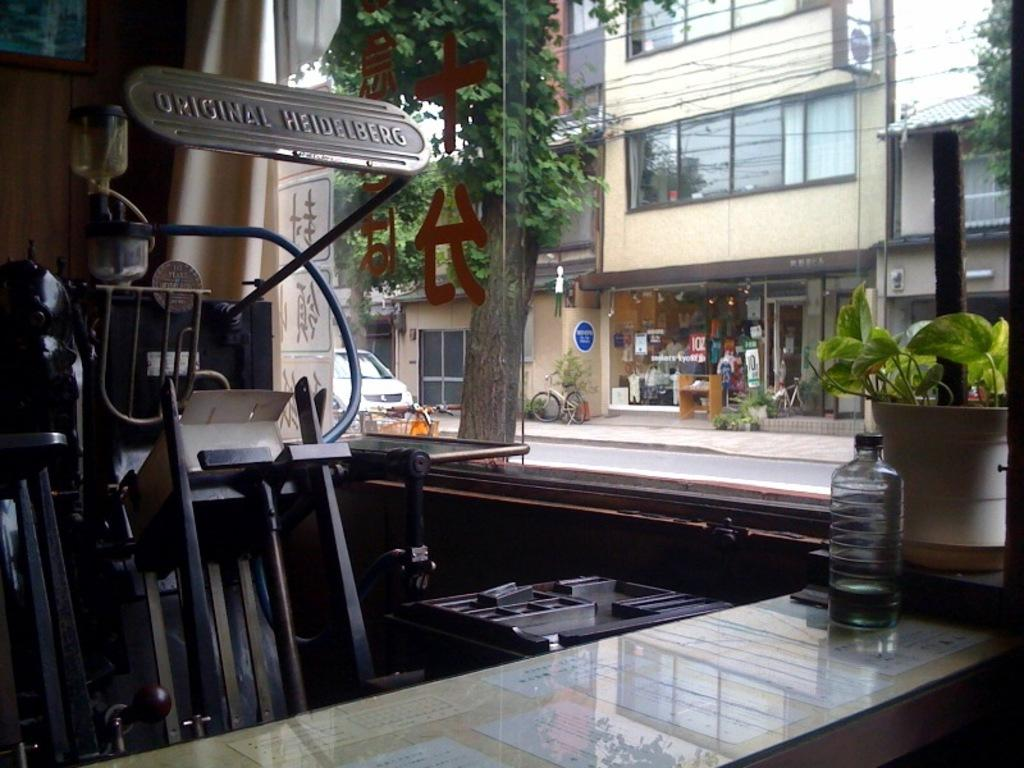<image>
Provide a brief description of the given image. The inside of a store with a banner of Original Heidelberg. 